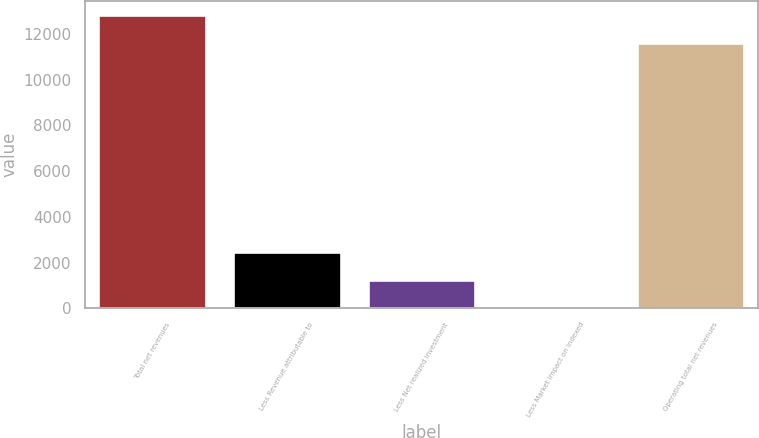Convert chart. <chart><loc_0><loc_0><loc_500><loc_500><bar_chart><fcel>Total net revenues<fcel>Less Revenue attributable to<fcel>Less Net realized investment<fcel>Less Market impact on indexed<fcel>Operating total net revenues<nl><fcel>12816.7<fcel>2462.4<fcel>1236.7<fcel>11<fcel>11591<nl></chart> 